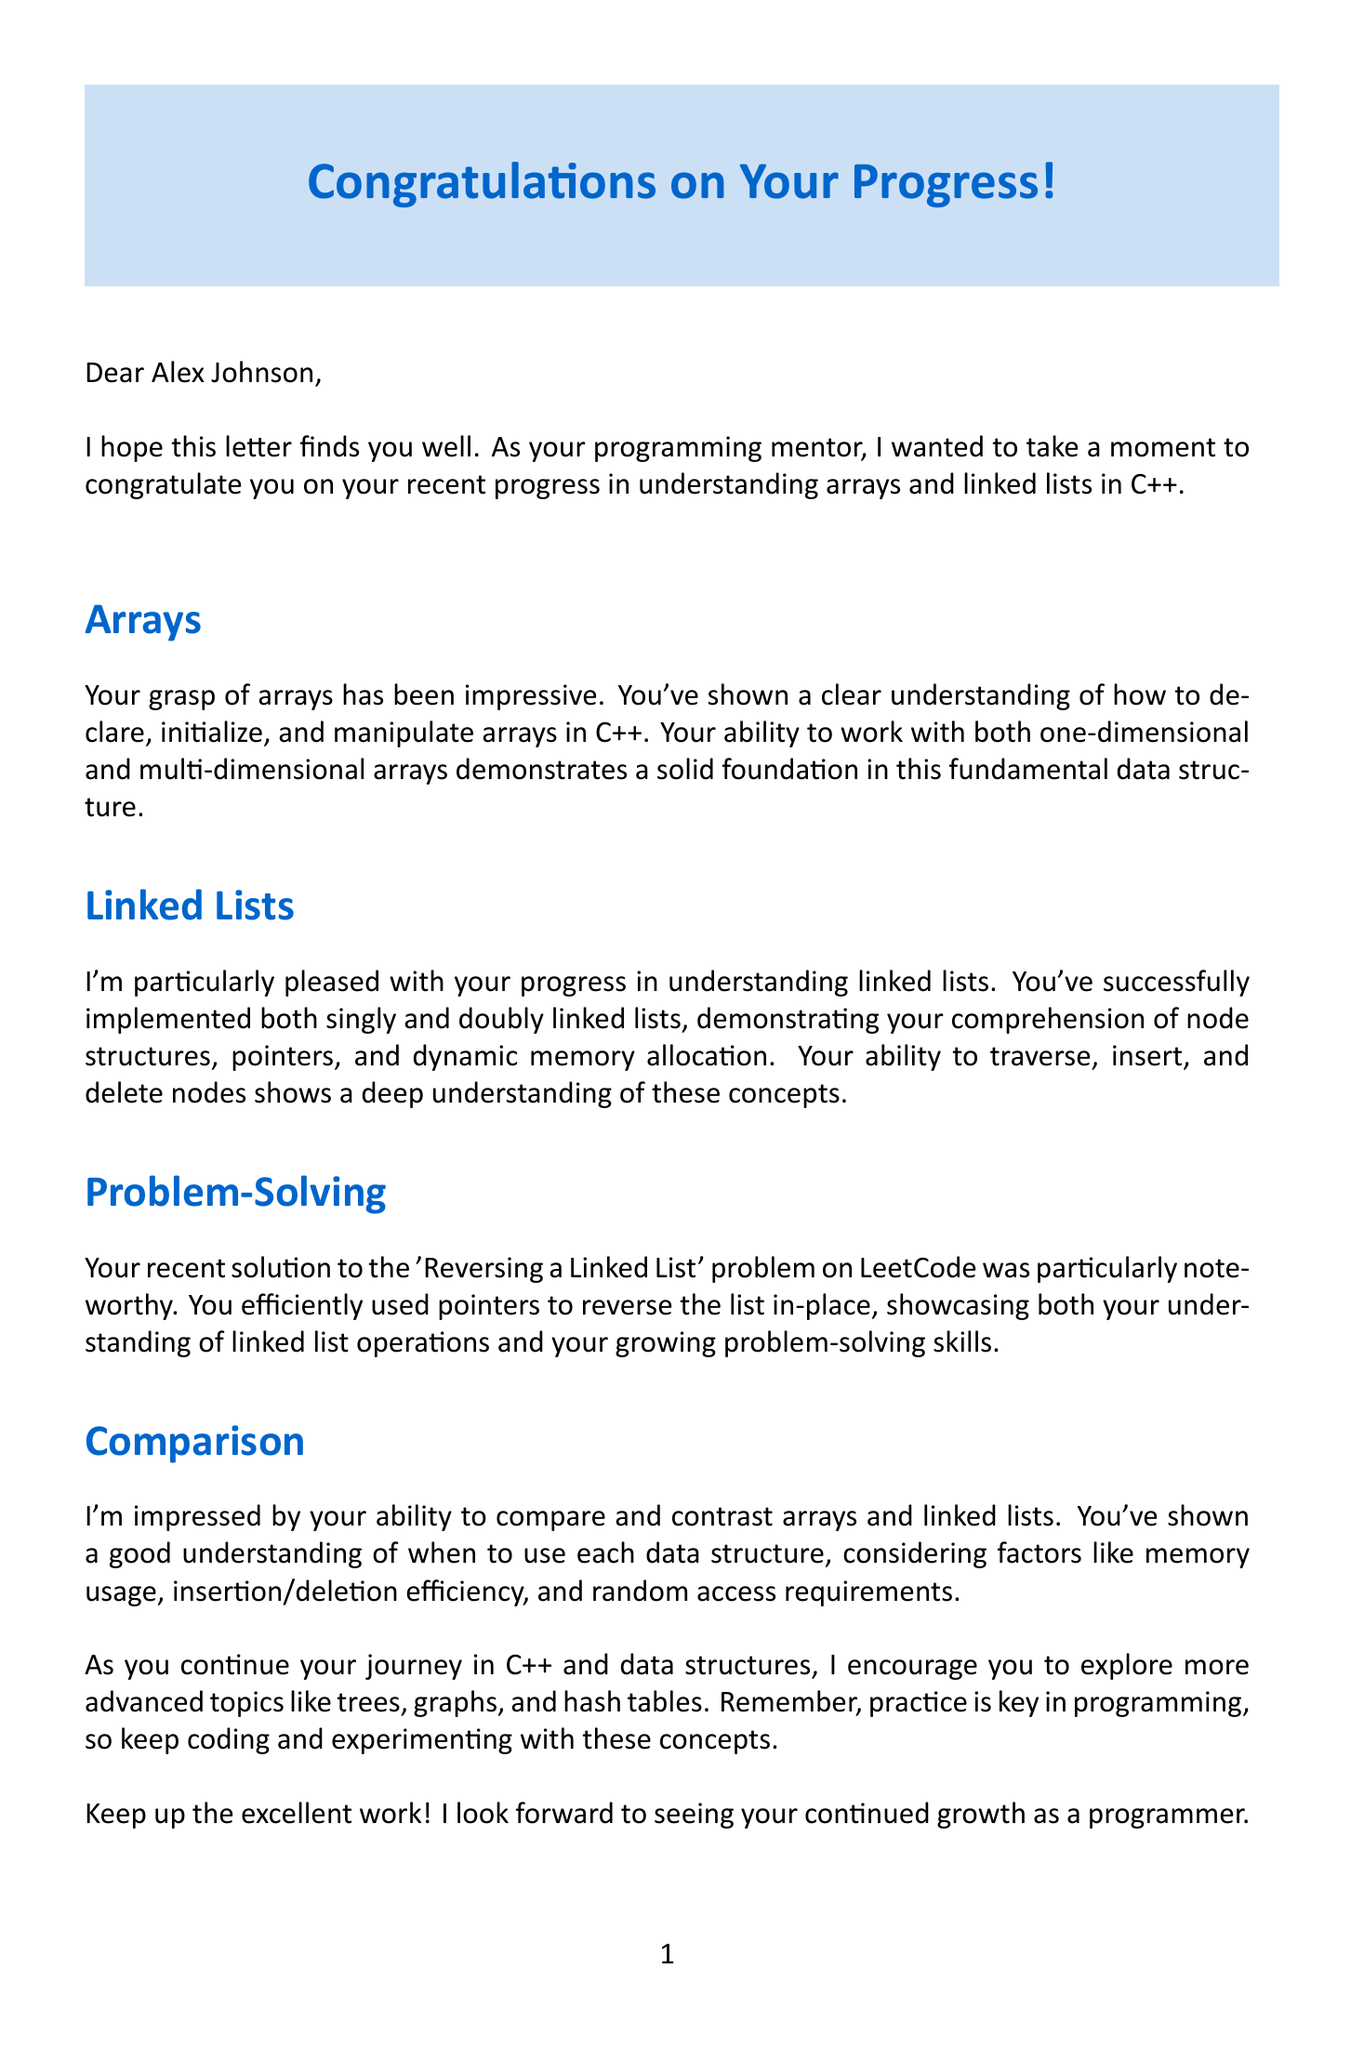What is the student's name? The student's name is mentioned in the salutation of the letter.
Answer: Alex Johnson Who is the mentor? The mentor's name is provided in the closing section of the letter.
Answer: Dr. Sarah Chen What is the position of the mentor? The mentor's position is stated near the end of the letter.
Answer: Senior Software Engineer Which university is the student attending? The university the student is enrolled in is mentioned in the student details section.
Answer: Stanford University What data structure is highlighted for the student's strong understanding? The document discusses the student's understanding of specific data structures.
Answer: Arrays What recent problem did the student solve on LeetCode? A specific problem that the student solved is stated in the problem-solving paragraph.
Answer: Reversing a Linked List How many years of experience does the mentor have? The mentor's experience is detailed in their introduction.
Answer: 15 years What two types of linked lists did the student implement? The document specifies the types of linked lists the student has worked with.
Answer: Singly and doubly linked lists What advanced topics does the mentor suggest exploring next? The mentor encourages the student to explore certain advanced topics.
Answer: Trees, graphs, and hash tables What is emphasized as key in programming? A motivational point made in the letter is about the importance of a particular practice.
Answer: Practice 